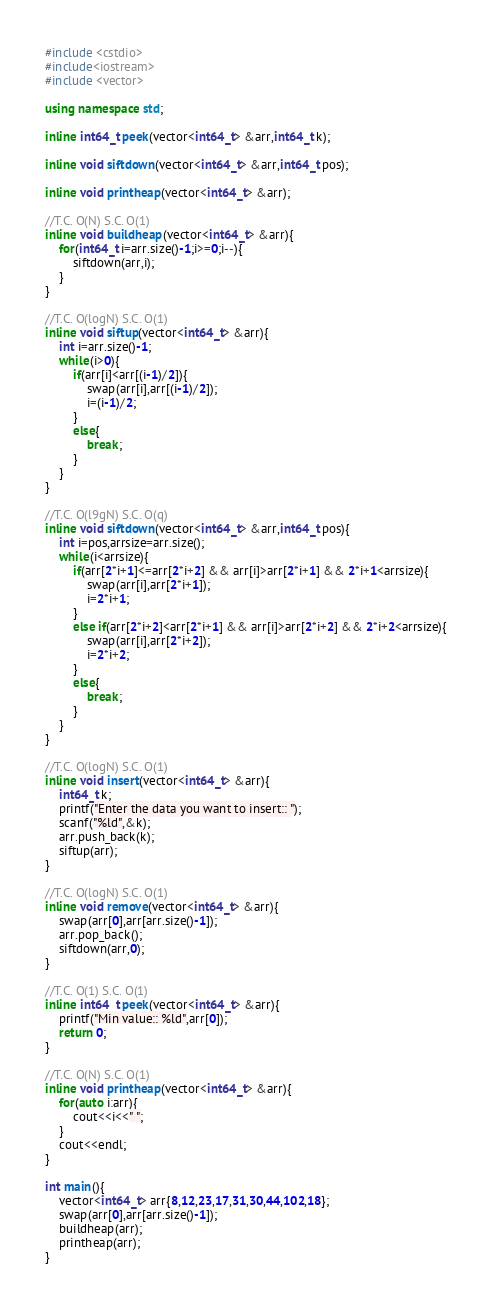Convert code to text. <code><loc_0><loc_0><loc_500><loc_500><_C++_>#include <cstdio>
#include<iostream>
#include <vector>

using namespace std;

inline int64_t peek(vector<int64_t> &arr,int64_t k);

inline void siftdown(vector<int64_t> &arr,int64_t pos);

inline void printheap(vector<int64_t> &arr);

//T.C. O(N) S.C. O(1)
inline void buildheap(vector<int64_t> &arr){
    for(int64_t i=arr.size()-1;i>=0;i--){
        siftdown(arr,i);
    }
}

//T.C. O(logN) S.C. O(1)
inline void siftup(vector<int64_t> &arr){
    int i=arr.size()-1;
    while(i>0){
        if(arr[i]<arr[(i-1)/2]){
            swap(arr[i],arr[(i-1)/2]);
            i=(i-1)/2;
        }
        else{
            break;
        }
    }
}

//T.C. O(l9gN) S.C. O(q)
inline void siftdown(vector<int64_t> &arr,int64_t pos){
    int i=pos,arrsize=arr.size();
    while(i<arrsize){
        if(arr[2*i+1]<=arr[2*i+2] && arr[i]>arr[2*i+1] && 2*i+1<arrsize){
            swap(arr[i],arr[2*i+1]);
            i=2*i+1;
        }
        else if(arr[2*i+2]<arr[2*i+1] && arr[i]>arr[2*i+2] && 2*i+2<arrsize){
            swap(arr[i],arr[2*i+2]);
            i=2*i+2;
        }
        else{
            break;
        }
    }
}

//T.C. O(logN) S.C. O(1)
inline void insert(vector<int64_t> &arr){
    int64_t k;
    printf("Enter the data you want to insert:: ");
    scanf("%ld",&k);
    arr.push_back(k);
    siftup(arr);
}

//T.C. O(logN) S.C. O(1)
inline void remove(vector<int64_t> &arr){
    swap(arr[0],arr[arr.size()-1]);
    arr.pop_back();
    siftdown(arr,0);
}

//T.C. O(1) S.C. O(1)
inline int64_t peek(vector<int64_t> &arr){
    printf("Min value:: %ld",arr[0]);
    return 0;
}

//T.C. O(N) S.C. O(1)
inline void printheap(vector<int64_t> &arr){
    for(auto i:arr){
        cout<<i<<" ";
    }
    cout<<endl;
}

int main(){
    vector<int64_t> arr{8,12,23,17,31,30,44,102,18};
    swap(arr[0],arr[arr.size()-1]);
    buildheap(arr);
    printheap(arr);
}
</code> 